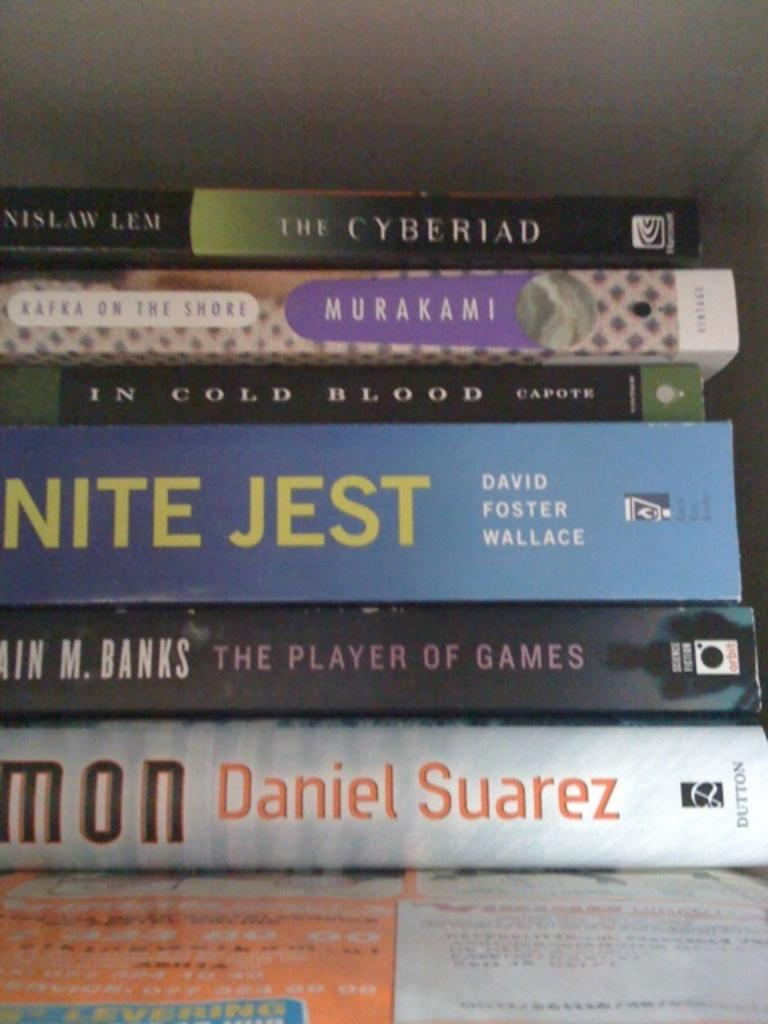<image>
Render a clear and concise summary of the photo. A stack of books with one titled the Cyberiad. 